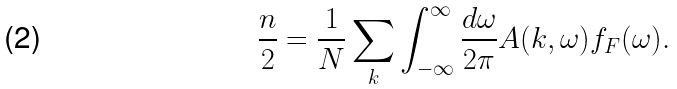<formula> <loc_0><loc_0><loc_500><loc_500>\frac { n } { 2 } = \frac { 1 } { N } \sum _ { k } \int ^ { \infty } _ { - \infty } \frac { d \omega } { 2 \pi } A ( { k } , \omega ) f _ { F } ( \omega ) .</formula> 